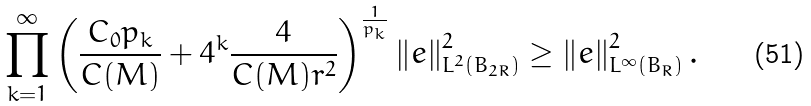Convert formula to latex. <formula><loc_0><loc_0><loc_500><loc_500>\prod _ { k = 1 } ^ { \infty } \left ( \frac { C _ { 0 } p _ { k } } { C ( M ) } + 4 ^ { k } \frac { 4 } { C ( M ) r ^ { 2 } } \right ) ^ { \frac { 1 } { p _ { k } } } \left \| e \right \| _ { L ^ { 2 } ( B _ { 2 R } ) } ^ { 2 } \geq \left \| e \right \| _ { L ^ { \infty } ( B _ { R } ) } ^ { 2 } .</formula> 